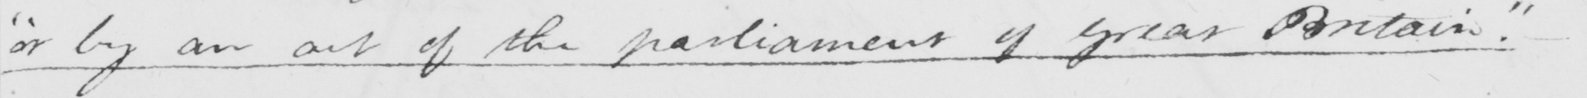What text is written in this handwritten line? " or by an act of the parliament of Great Britain .  " 